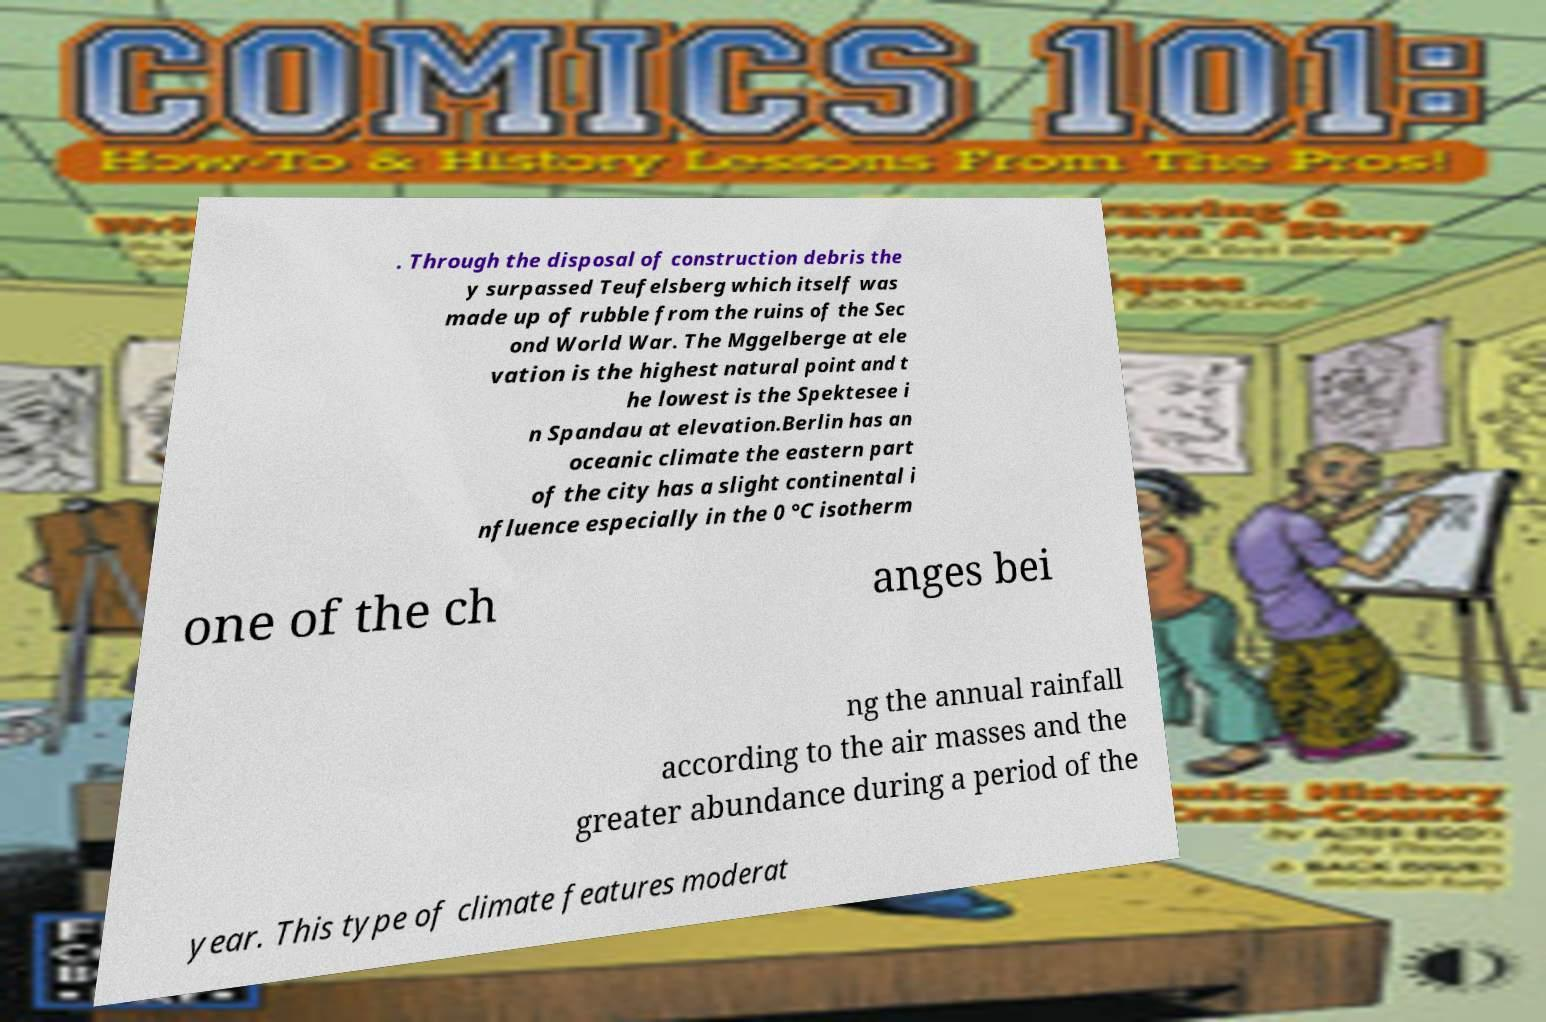I need the written content from this picture converted into text. Can you do that? . Through the disposal of construction debris the y surpassed Teufelsberg which itself was made up of rubble from the ruins of the Sec ond World War. The Mggelberge at ele vation is the highest natural point and t he lowest is the Spektesee i n Spandau at elevation.Berlin has an oceanic climate the eastern part of the city has a slight continental i nfluence especially in the 0 °C isotherm one of the ch anges bei ng the annual rainfall according to the air masses and the greater abundance during a period of the year. This type of climate features moderat 